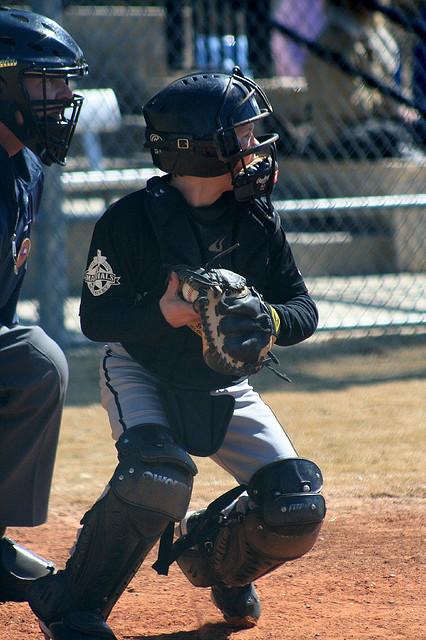What is the boy about to do?
Concise answer only. Throw ball. Does this appear to be a professional or recreational sport league?
Answer briefly. Recreational. What is on the boy's legs?
Short answer required. Knee pads. 